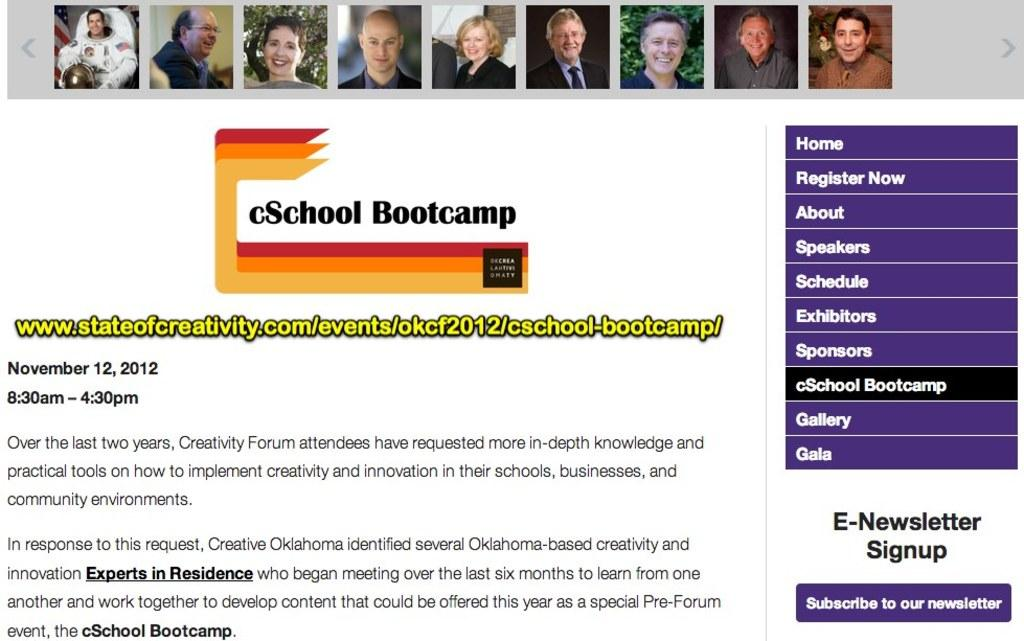What can be seen in the image? There are pictures in the image. What are the people in the pictures doing? Some of the people in the pictures are smiling. What else is present in the image besides the pictures? There are words and numbers written in the image. What is the color of the background in the image? The background of the image is white. How many hydrants can be seen in the image? There are no hydrants present in the image. What type of bubble is floating near the words and numbers? There is no bubble present in the image. 